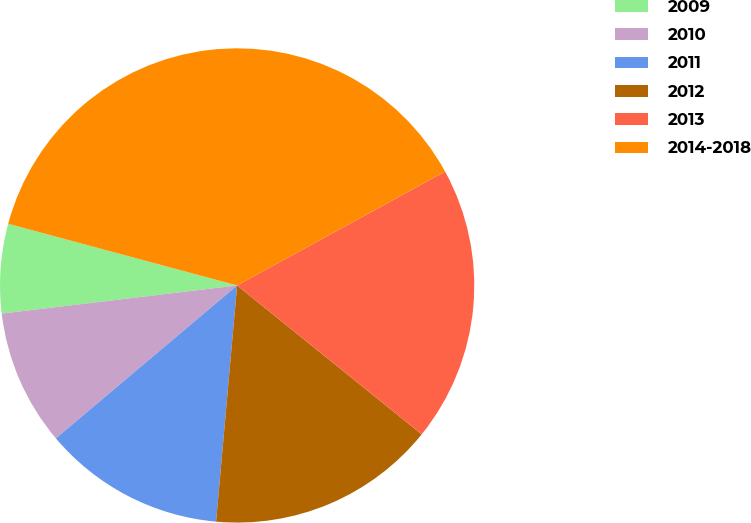Convert chart to OTSL. <chart><loc_0><loc_0><loc_500><loc_500><pie_chart><fcel>2009<fcel>2010<fcel>2011<fcel>2012<fcel>2013<fcel>2014-2018<nl><fcel>6.08%<fcel>9.26%<fcel>12.43%<fcel>15.61%<fcel>18.78%<fcel>37.83%<nl></chart> 